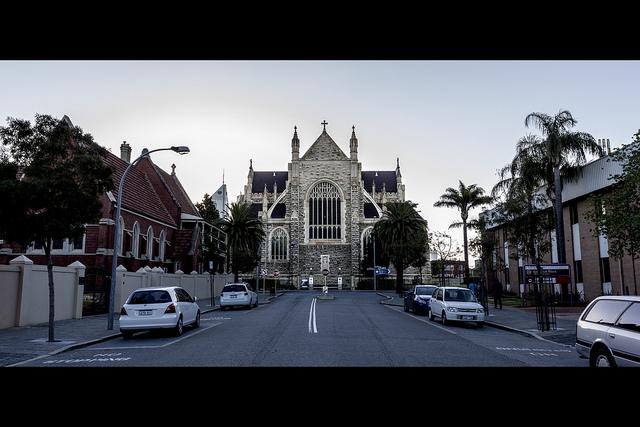What is the picture capturing?
Be succinct. Church. Are the passengers of this vehicle relaxed?
Keep it brief. No. What year was the car made on the left hand side of the photograph?
Give a very brief answer. 2000. Can the people get to the other side of the road?
Answer briefly. Yes. Do you see any train tracks?
Be succinct. No. What is in front of the building?
Give a very brief answer. Street. Is there a clock in the building?
Write a very short answer. No. Is this a romantic setting for a date?
Short answer required. No. How many vehicles are in this image?
Short answer required. 5. Is this a one way street?
Answer briefly. No. Are the cars moving?
Be succinct. No. Was the photo taken during the day?
Keep it brief. Yes. Is there any lines on the street?
Answer briefly. Yes. Is there a clock in the photo?
Answer briefly. No. How many busses are in this picture?
Short answer required. 0. Is the tower in the distance a clock tower?
Keep it brief. No. What vehicle is in the picture?
Keep it brief. Cars. How many wheels are pictured?
Concise answer only. 9. Are the cars parked facing inwards?
Give a very brief answer. No. Is there a wheel on the ground?
Be succinct. Yes. Are there cars here?
Quick response, please. Yes. Which side of the car is this?
Write a very short answer. Passenger. 